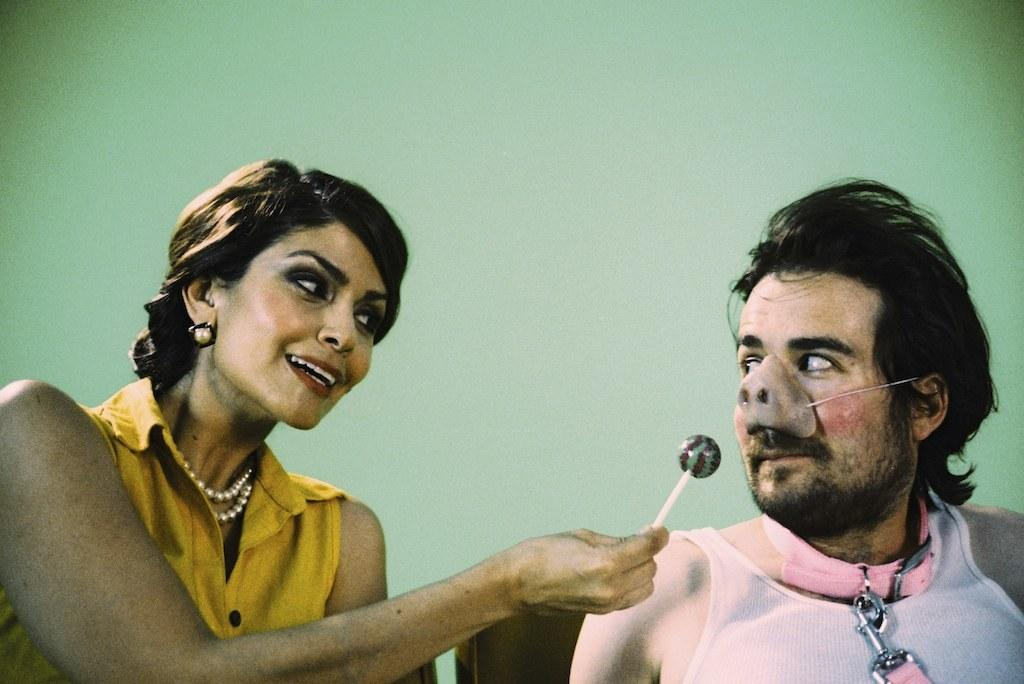What can be seen in the background of the image? There is a wall in the image. What are the people in the image doing? Two people are sitting on chairs in the image. Can you describe one of the people in the image? One of the people is a woman, and she is wearing a yellow dress. What is the woman holding in the image? The woman is holding a lollipop. Is there a volcano erupting in the background of the image? No, there is no volcano present in the image. What type of pickle is the woman eating in the image? There is no pickle present in the image; the woman is holding a lollipop. 